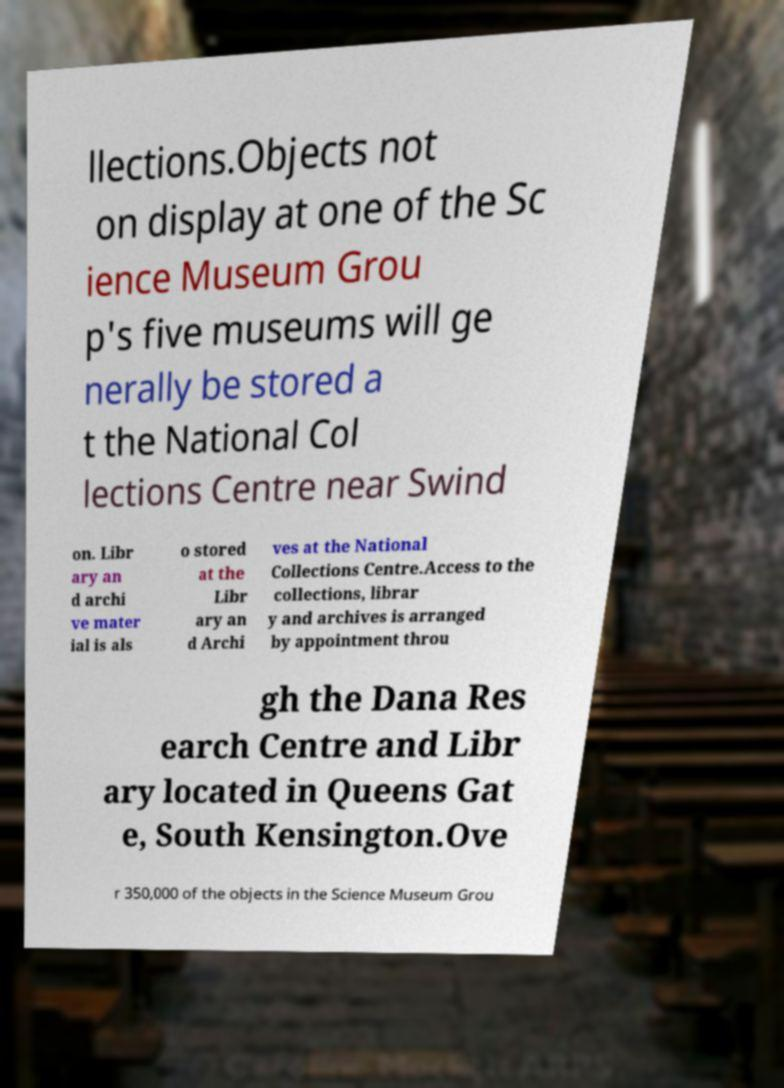Could you extract and type out the text from this image? llections.Objects not on display at one of the Sc ience Museum Grou p's five museums will ge nerally be stored a t the National Col lections Centre near Swind on. Libr ary an d archi ve mater ial is als o stored at the Libr ary an d Archi ves at the National Collections Centre.Access to the collections, librar y and archives is arranged by appointment throu gh the Dana Res earch Centre and Libr ary located in Queens Gat e, South Kensington.Ove r 350,000 of the objects in the Science Museum Grou 